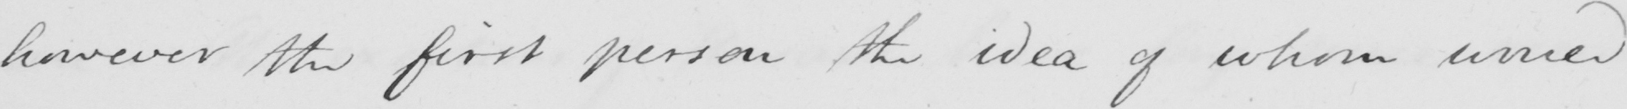What does this handwritten line say? however the first person the idea of whom would 